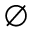<formula> <loc_0><loc_0><loc_500><loc_500>\emptyset</formula> 